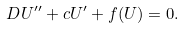Convert formula to latex. <formula><loc_0><loc_0><loc_500><loc_500>D U ^ { \prime \prime } + c U ^ { \prime } + f ( U ) = 0 .</formula> 